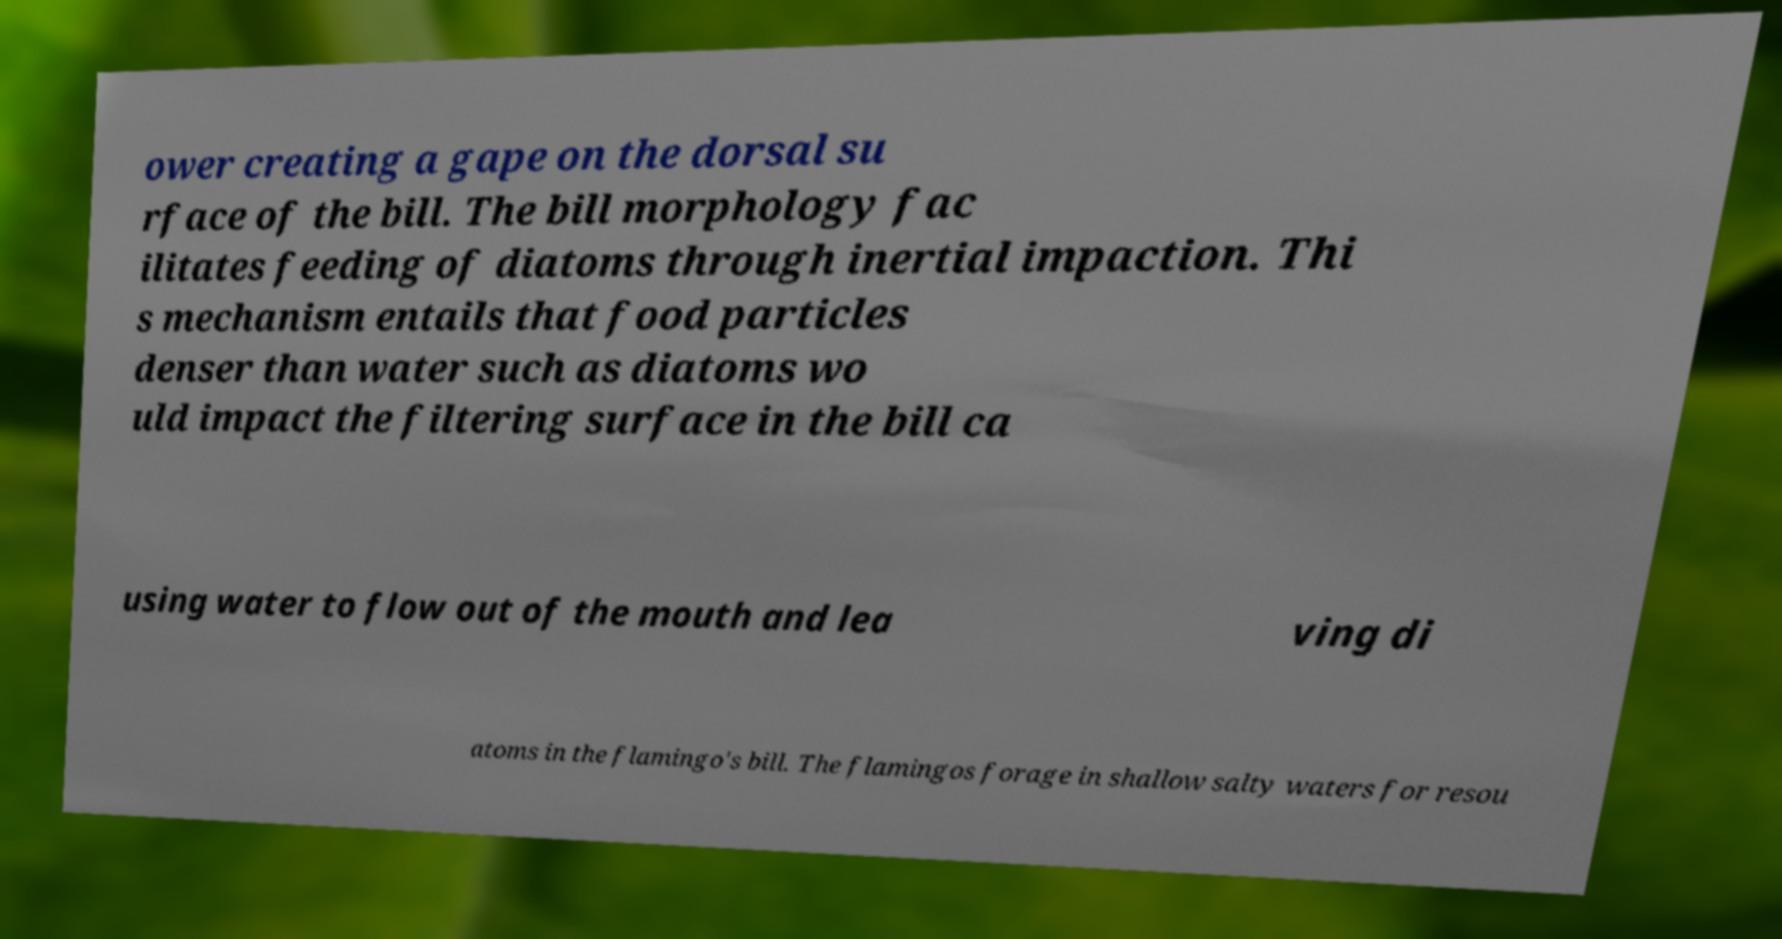I need the written content from this picture converted into text. Can you do that? ower creating a gape on the dorsal su rface of the bill. The bill morphology fac ilitates feeding of diatoms through inertial impaction. Thi s mechanism entails that food particles denser than water such as diatoms wo uld impact the filtering surface in the bill ca using water to flow out of the mouth and lea ving di atoms in the flamingo's bill. The flamingos forage in shallow salty waters for resou 